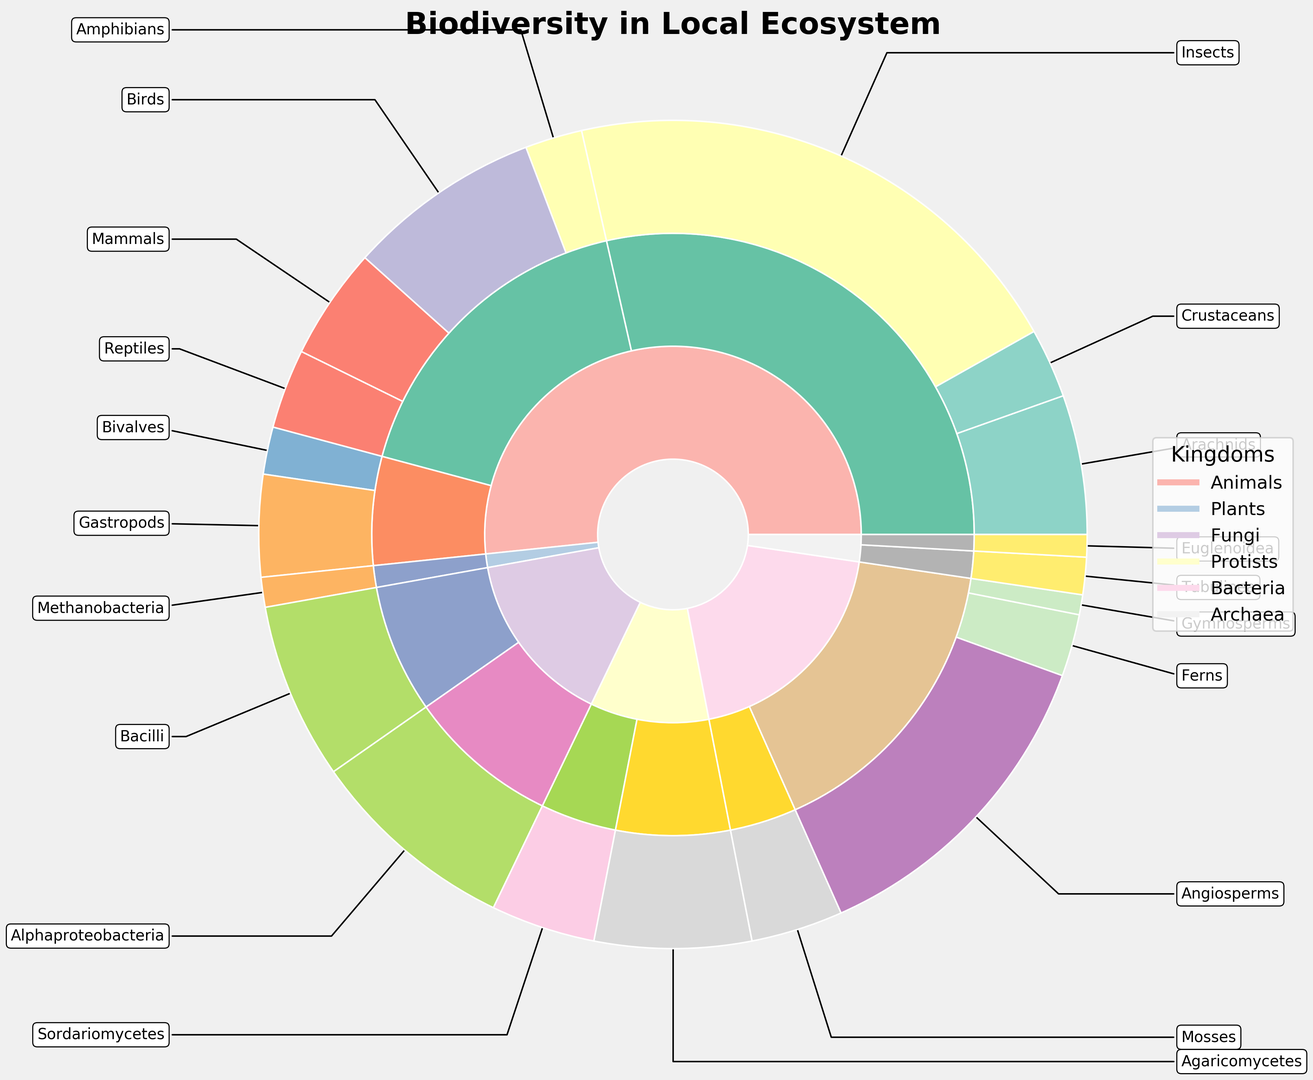What is the most common kingdom in the ecosystem? Look at the innermost circle of the nested pie chart to see which segment has the largest size. The kingdom with the largest segment is "Animals".
Answer: Animals What is the total number of Angiosperms and Gymnosperms in the ecosystem? Find the counts for Angiosperms (132) and Gymnosperms (8) in the outermost circle representing classes. Sum these values: 132 + 8 = 140.
Answer: 140 Which phylum has more species: Arthropoda or Chordata? Examine the middle circle representing phylums within the "Animals" kingdom. Compare the sizes of Arthropoda and Chordata segments. Arthropoda has more species.
Answer: Arthropoda What is the ratio of Mammals to Birds in the Chordata phylum? Identify the segments for Mammals (45) and Birds (78) in the outermost circle under Chordata. Calculate the ratio as 45:78, which simplifies to 5:9.
Answer: 5:9 Which class has the smallest count in the Fungi kingdom? Look at the outermost circle for classes within the Fungi kingdom. Compare the segments for Agaricomycetes (63) and Sordariomycetes (42). Sordariomycetes has the smallest count.
Answer: Sordariomycetes How many more Insects are there than Reptiles in the ecosystem? Find the counts for Insects (210) and Reptiles (32) in the outermost circle. Subtract the count of Reptiles from Insects: 210 - 32 = 178.
Answer: 178 What is the proportion of species in the Bacteria kingdom compared to those in the Archaea kingdom? Determine the slice sizes of the Bacteria (sum of Alphaproteobacteria and Bacilli, 84 + 71 = 155) and Archaea (Methanobacteria, 12) kingdoms in the innermost circle. The proportion is 155:12.
Answer: 155:12 Which kingdom has the greatest biodiversity in terms of the number of classes represented? Count the number of unique classes within each kingdom segment in the outermost circle. "Animals" has the largest number of unique classes represented.
Answer: Animals Are there more classes within the Tracheophyta phylum or the Arthropoda phylum? Identify the unique classes in the middle circle within Tracheophyta (3 classes: Angiosperms, Gymnosperms, Ferns) and compare it to Arthropoda (3 classes: Insects, Arachnids, Crustaceans). Both have an equal number of classes.
Answer: Equal Which class has more species: Bacilli in the Bacteria kingdom or Gastropods in the Animals kingdom? Compare the counts for Bacilli (71) in the Bacteria kingdom and Gastropods (41) in the Animals kingdom in the outermost circle. Bacilli have more species.
Answer: Bacilli 